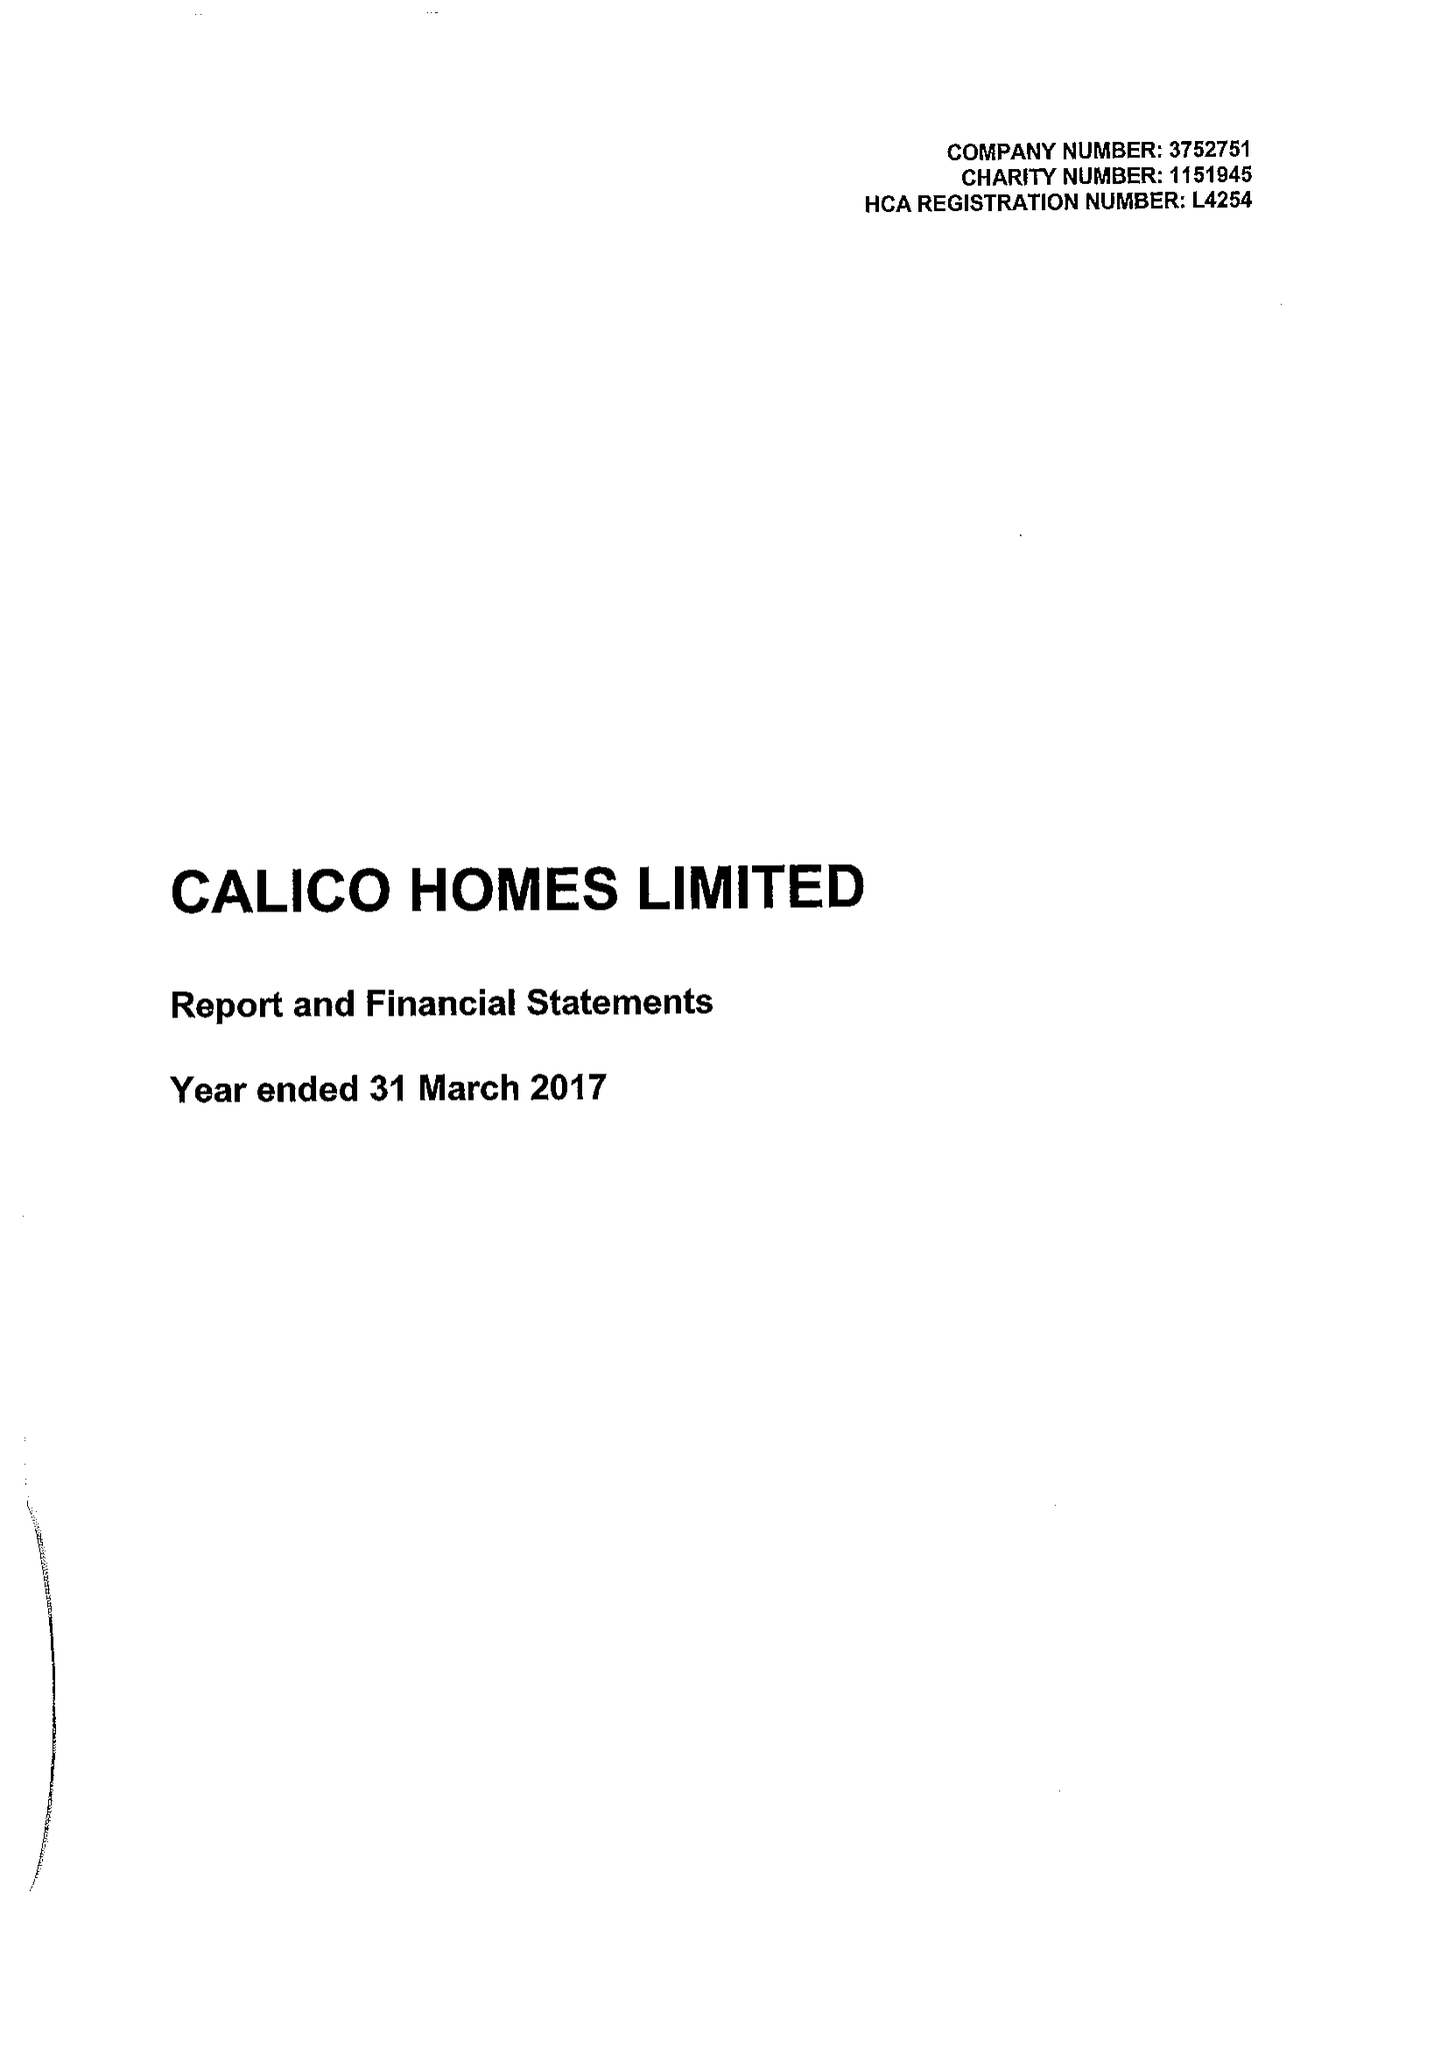What is the value for the spending_annually_in_british_pounds?
Answer the question using a single word or phrase. 21233000.00 